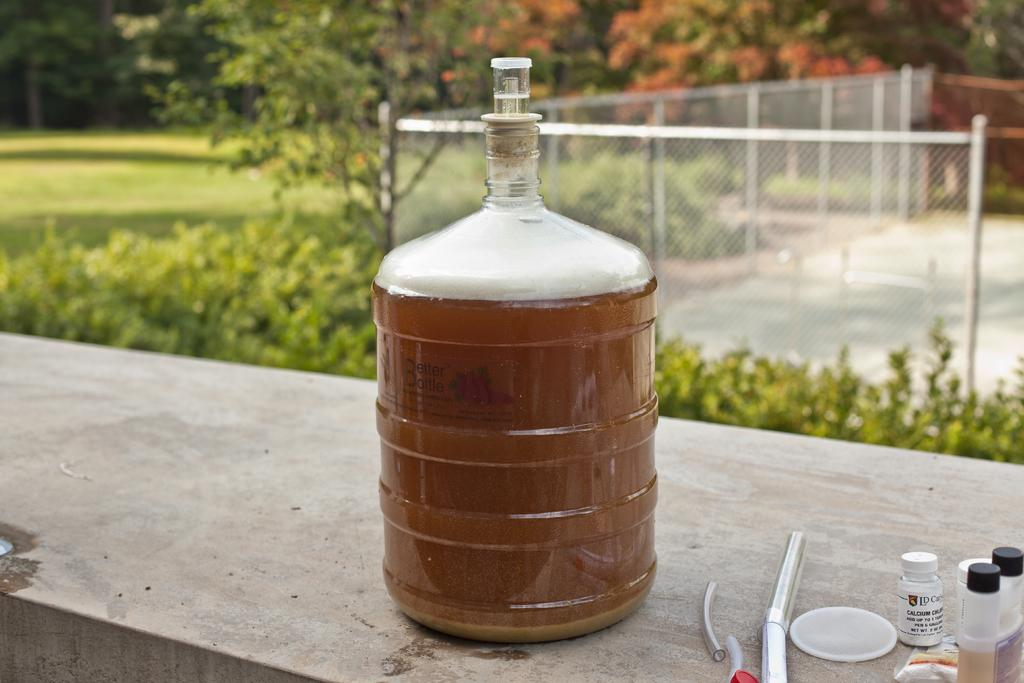What type of container is visible in the image? There is a can in the image. What other containers can be seen in the image? There are bottles in the image. What is visible in the background of the image? There is a fence, plants, and trees in the background of the image. What type of writing can be seen on the can in the image? There is no writing visible on the can in the image. How many frogs are sitting on the bottles in the image? There are no frogs present in the image. 